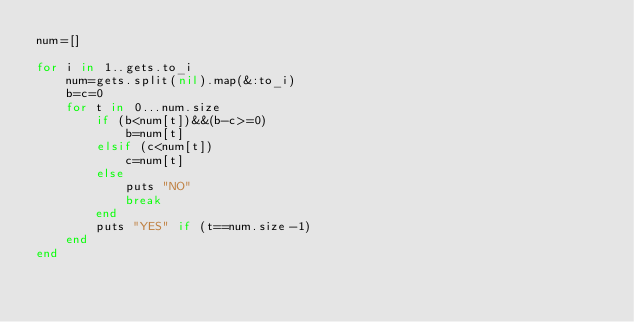Convert code to text. <code><loc_0><loc_0><loc_500><loc_500><_Ruby_>num=[]

for i in 1..gets.to_i
    num=gets.split(nil).map(&:to_i)
    b=c=0
    for t in 0...num.size
        if (b<num[t])&&(b-c>=0)
            b=num[t]
        elsif (c<num[t])
            c=num[t]
        else
            puts "NO"
            break
        end
        puts "YES" if (t==num.size-1)
    end
end</code> 